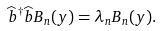Convert formula to latex. <formula><loc_0><loc_0><loc_500><loc_500>\widehat { b } ^ { \dagger } \widehat { b } B _ { n } ( y ) = \lambda _ { n } B _ { n } ( y ) .</formula> 